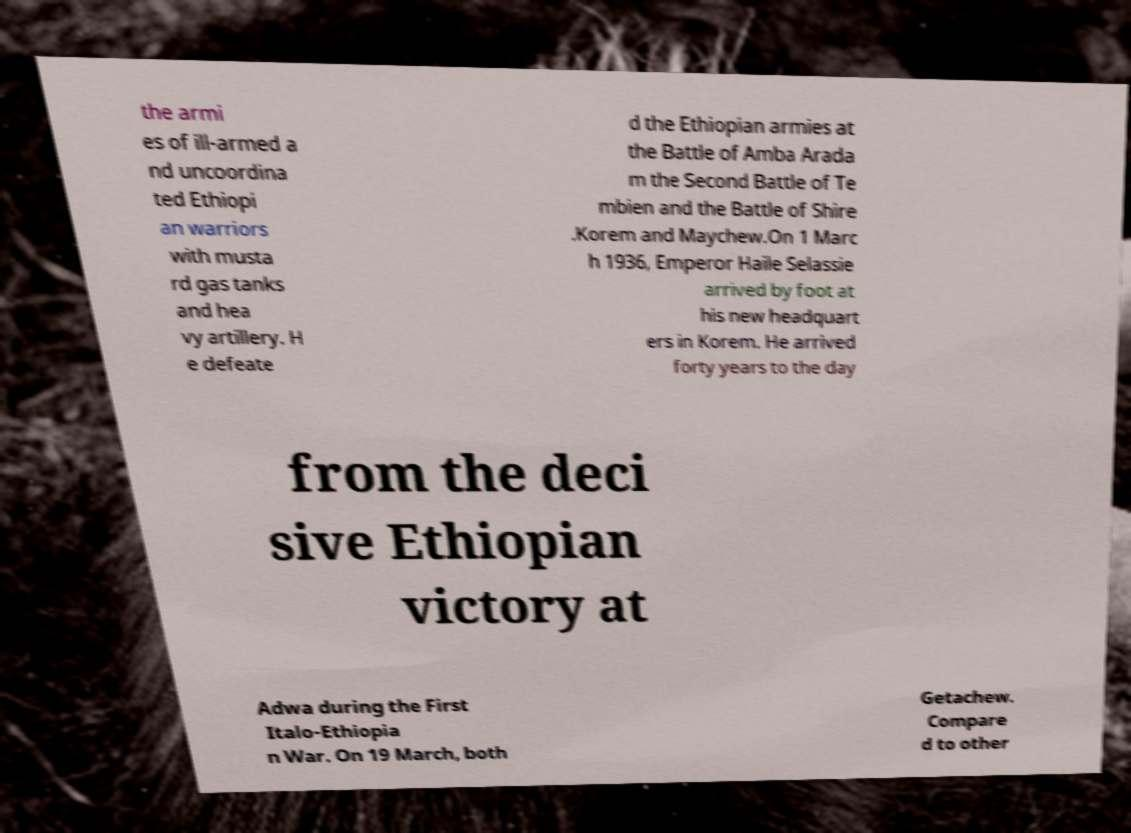Could you extract and type out the text from this image? the armi es of ill-armed a nd uncoordina ted Ethiopi an warriors with musta rd gas tanks and hea vy artillery. H e defeate d the Ethiopian armies at the Battle of Amba Arada m the Second Battle of Te mbien and the Battle of Shire .Korem and Maychew.On 1 Marc h 1936, Emperor Haile Selassie arrived by foot at his new headquart ers in Korem. He arrived forty years to the day from the deci sive Ethiopian victory at Adwa during the First Italo-Ethiopia n War. On 19 March, both Getachew. Compare d to other 